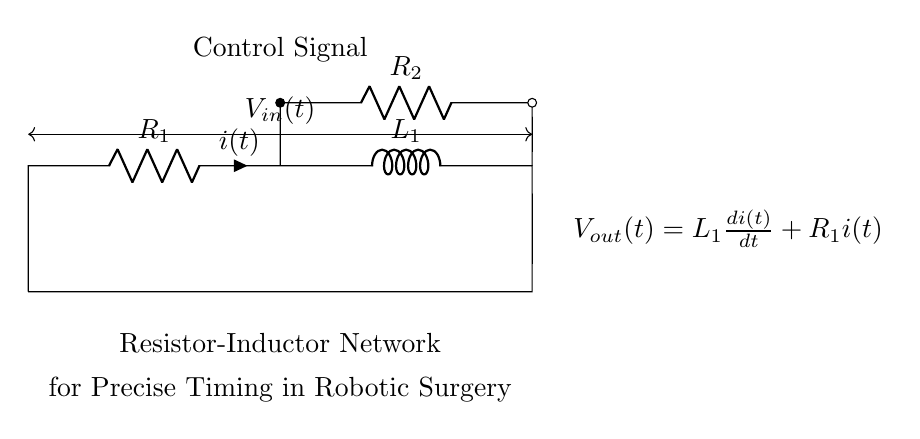What are the components in the circuit? The circuit contains two resistors and one inductor, identified as R1, R2, and L1.
Answer: Resistor, Inductor What is the current notation in the circuit? The current is represented by 'i(t)' flowing through R1 and L1 as shown by the label on the current arrow.
Answer: i(t) What does the output voltage represent? The output voltage, Vout(t), is expressed by the equation containing the inductor's rate of change and the resistive current, showing the relationship between current and voltage in dynamic conditions.
Answer: L1 di(t)/dt + R1 i(t) What is the purpose of the control signal in the circuit? The control signal connects to R2, which likely regulates the operation or timing of the resistive-inductive network relative to input and output.
Answer: Regulation What will happen if R1 is increased in value? Increasing R1 will impact the time constant of the circuit, which relies on both R and L. A larger R1 will lead to slower charging and discharging in timing applications, affecting device precision.
Answer: Longer timing How does the inductor influence the circuit dynamics? The inductor L1 introduces inductive reactance, influencing how quickly the circuit responds to changes in current, which is critical in timing applications within robotic surgery.
Answer: Delays response What type of timing behavior does this network provide? The resistor-inductor network yields a time constant based on R1 and L1 together, defining the speed at which the circuit reacts to control signals, allowing for fine-tuning in surgical applications.
Answer: Precise timing 